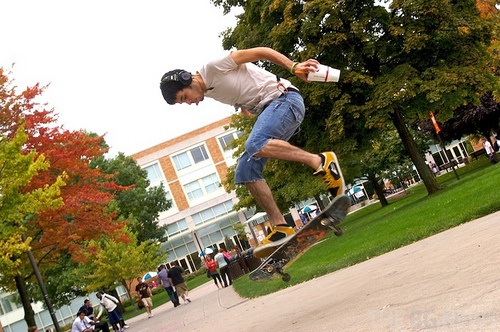Describe the objects in this image and their specific colors. I can see people in white, gray, black, and tan tones, skateboard in white, black, darkgreen, maroon, and gray tones, people in white, black, lightgray, darkgray, and gray tones, people in white, black, olive, gray, and maroon tones, and people in white, black, and gray tones in this image. 